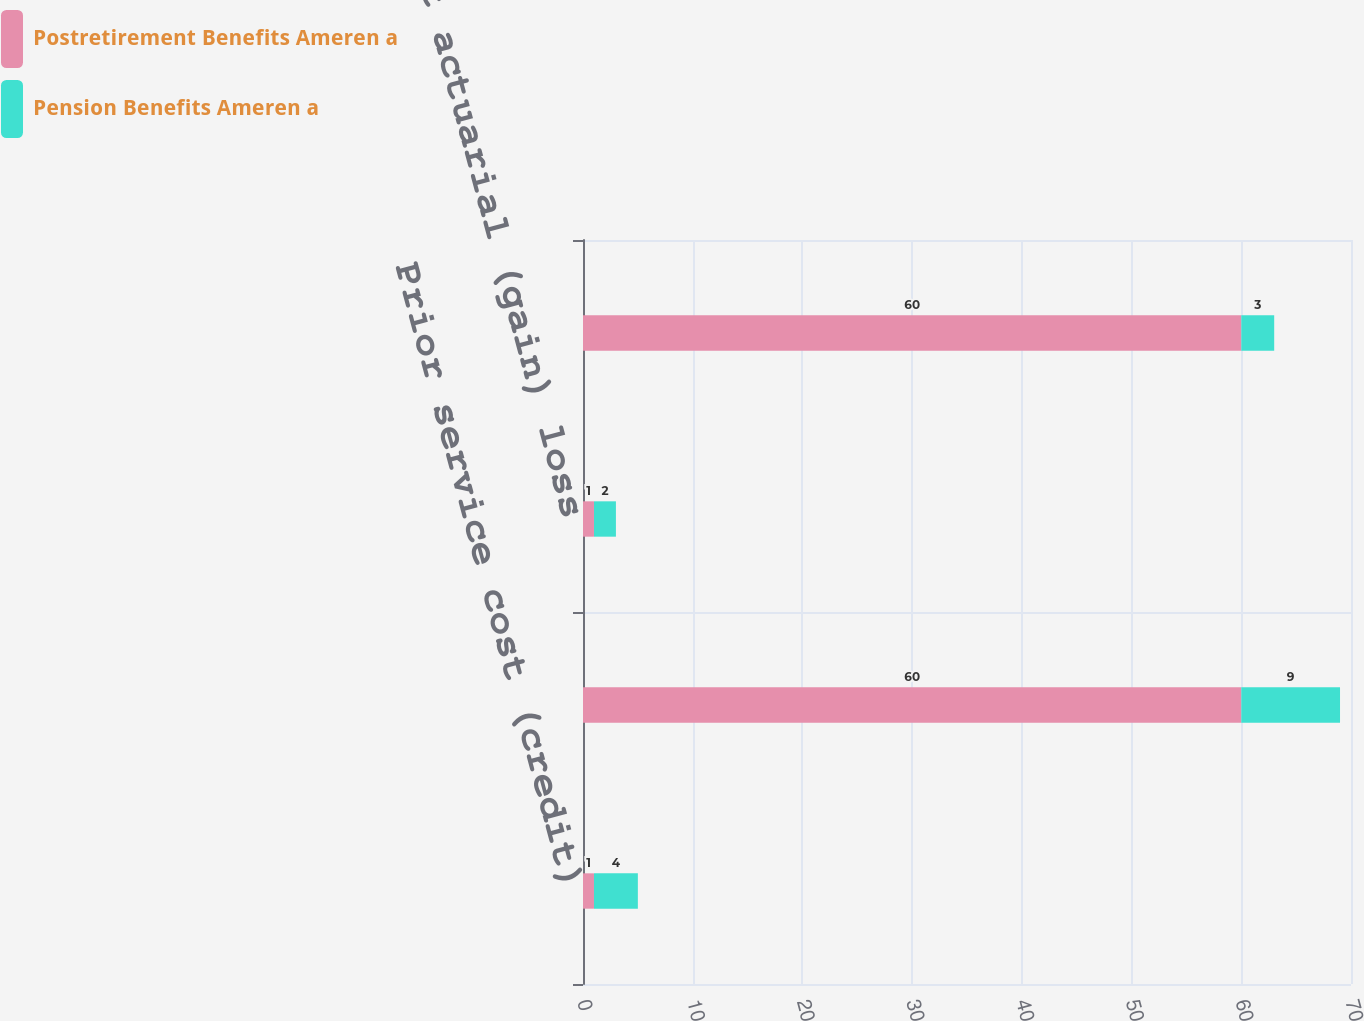Convert chart to OTSL. <chart><loc_0><loc_0><loc_500><loc_500><stacked_bar_chart><ecel><fcel>Prior service cost (credit)<fcel>Net actuarial loss<fcel>Net actuarial (gain) loss<fcel>Total<nl><fcel>Postretirement Benefits Ameren a<fcel>1<fcel>60<fcel>1<fcel>60<nl><fcel>Pension Benefits Ameren a<fcel>4<fcel>9<fcel>2<fcel>3<nl></chart> 